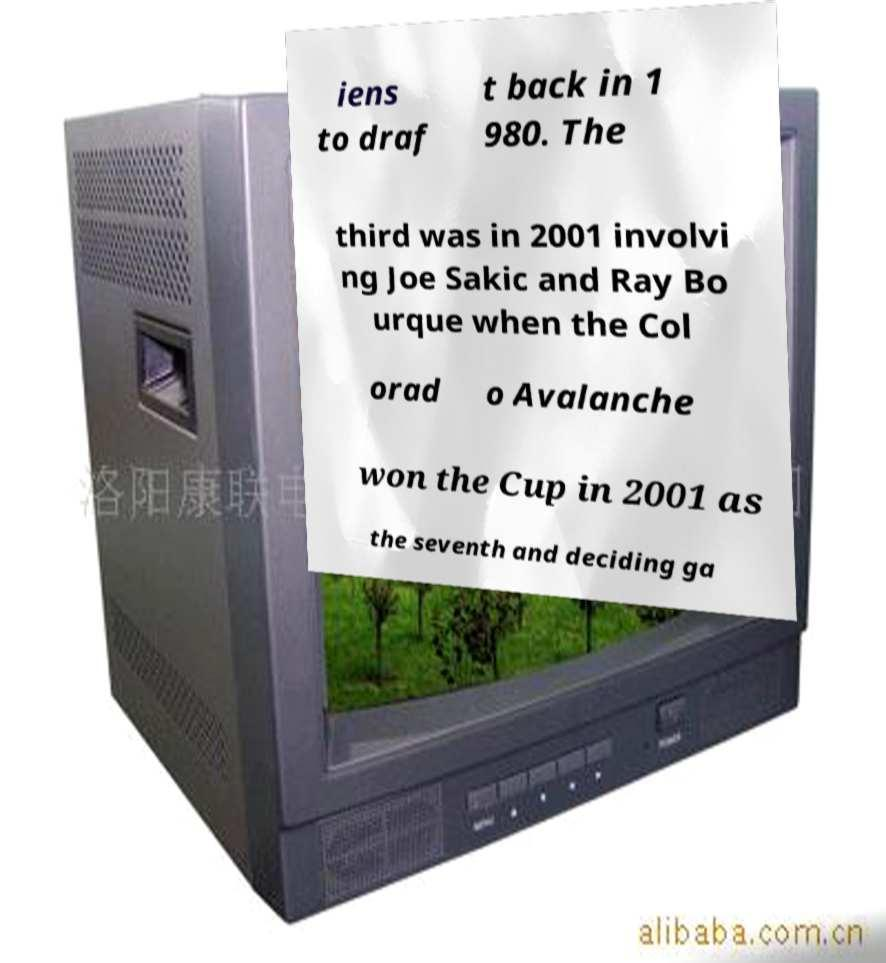Could you assist in decoding the text presented in this image and type it out clearly? iens to draf t back in 1 980. The third was in 2001 involvi ng Joe Sakic and Ray Bo urque when the Col orad o Avalanche won the Cup in 2001 as the seventh and deciding ga 